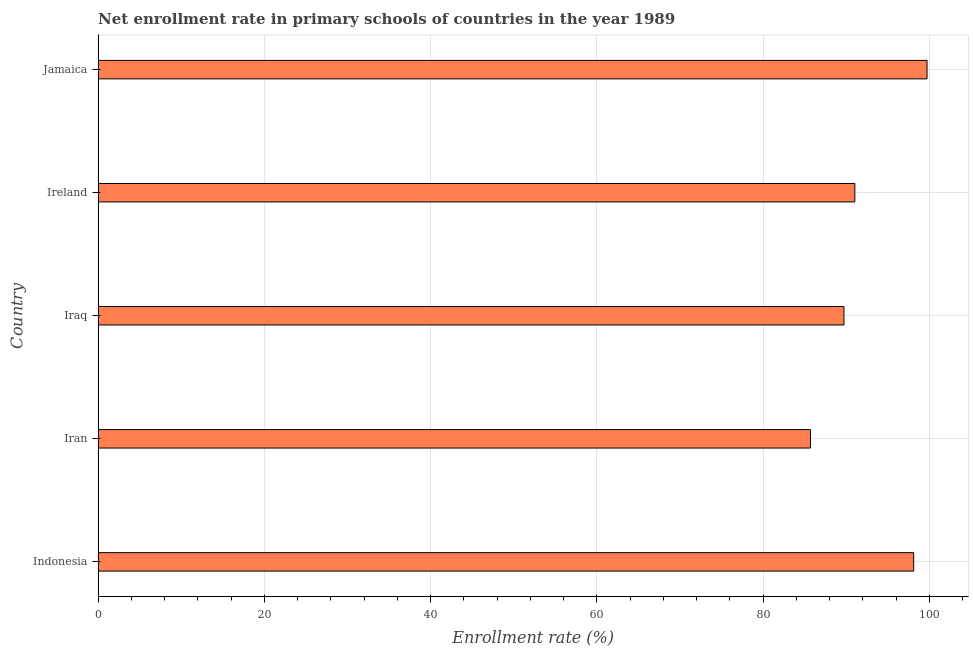What is the title of the graph?
Offer a terse response. Net enrollment rate in primary schools of countries in the year 1989. What is the label or title of the X-axis?
Ensure brevity in your answer.  Enrollment rate (%). What is the net enrollment rate in primary schools in Indonesia?
Give a very brief answer. 98.1. Across all countries, what is the maximum net enrollment rate in primary schools?
Keep it short and to the point. 99.71. Across all countries, what is the minimum net enrollment rate in primary schools?
Your answer should be very brief. 85.69. In which country was the net enrollment rate in primary schools maximum?
Offer a terse response. Jamaica. In which country was the net enrollment rate in primary schools minimum?
Offer a terse response. Iran. What is the sum of the net enrollment rate in primary schools?
Give a very brief answer. 464.22. What is the difference between the net enrollment rate in primary schools in Indonesia and Jamaica?
Your answer should be very brief. -1.61. What is the average net enrollment rate in primary schools per country?
Offer a terse response. 92.84. What is the median net enrollment rate in primary schools?
Ensure brevity in your answer.  91.02. In how many countries, is the net enrollment rate in primary schools greater than 12 %?
Make the answer very short. 5. What is the ratio of the net enrollment rate in primary schools in Ireland to that in Jamaica?
Provide a short and direct response. 0.91. Is the difference between the net enrollment rate in primary schools in Iraq and Ireland greater than the difference between any two countries?
Provide a succinct answer. No. What is the difference between the highest and the second highest net enrollment rate in primary schools?
Give a very brief answer. 1.61. Is the sum of the net enrollment rate in primary schools in Indonesia and Iran greater than the maximum net enrollment rate in primary schools across all countries?
Your response must be concise. Yes. What is the difference between the highest and the lowest net enrollment rate in primary schools?
Provide a short and direct response. 14.02. In how many countries, is the net enrollment rate in primary schools greater than the average net enrollment rate in primary schools taken over all countries?
Offer a very short reply. 2. Are the values on the major ticks of X-axis written in scientific E-notation?
Ensure brevity in your answer.  No. What is the Enrollment rate (%) of Indonesia?
Offer a terse response. 98.1. What is the Enrollment rate (%) in Iran?
Keep it short and to the point. 85.69. What is the Enrollment rate (%) in Iraq?
Give a very brief answer. 89.71. What is the Enrollment rate (%) of Ireland?
Your answer should be very brief. 91.02. What is the Enrollment rate (%) in Jamaica?
Ensure brevity in your answer.  99.71. What is the difference between the Enrollment rate (%) in Indonesia and Iran?
Ensure brevity in your answer.  12.41. What is the difference between the Enrollment rate (%) in Indonesia and Iraq?
Your answer should be compact. 8.38. What is the difference between the Enrollment rate (%) in Indonesia and Ireland?
Offer a very short reply. 7.08. What is the difference between the Enrollment rate (%) in Indonesia and Jamaica?
Keep it short and to the point. -1.61. What is the difference between the Enrollment rate (%) in Iran and Iraq?
Offer a very short reply. -4.03. What is the difference between the Enrollment rate (%) in Iran and Ireland?
Give a very brief answer. -5.33. What is the difference between the Enrollment rate (%) in Iran and Jamaica?
Provide a succinct answer. -14.02. What is the difference between the Enrollment rate (%) in Iraq and Ireland?
Offer a terse response. -1.31. What is the difference between the Enrollment rate (%) in Iraq and Jamaica?
Your answer should be compact. -10. What is the difference between the Enrollment rate (%) in Ireland and Jamaica?
Keep it short and to the point. -8.69. What is the ratio of the Enrollment rate (%) in Indonesia to that in Iran?
Offer a terse response. 1.15. What is the ratio of the Enrollment rate (%) in Indonesia to that in Iraq?
Your answer should be very brief. 1.09. What is the ratio of the Enrollment rate (%) in Indonesia to that in Ireland?
Keep it short and to the point. 1.08. What is the ratio of the Enrollment rate (%) in Iran to that in Iraq?
Keep it short and to the point. 0.95. What is the ratio of the Enrollment rate (%) in Iran to that in Ireland?
Offer a very short reply. 0.94. What is the ratio of the Enrollment rate (%) in Iran to that in Jamaica?
Make the answer very short. 0.86. What is the ratio of the Enrollment rate (%) in Iraq to that in Ireland?
Provide a succinct answer. 0.99. What is the ratio of the Enrollment rate (%) in Iraq to that in Jamaica?
Your answer should be compact. 0.9. What is the ratio of the Enrollment rate (%) in Ireland to that in Jamaica?
Offer a terse response. 0.91. 